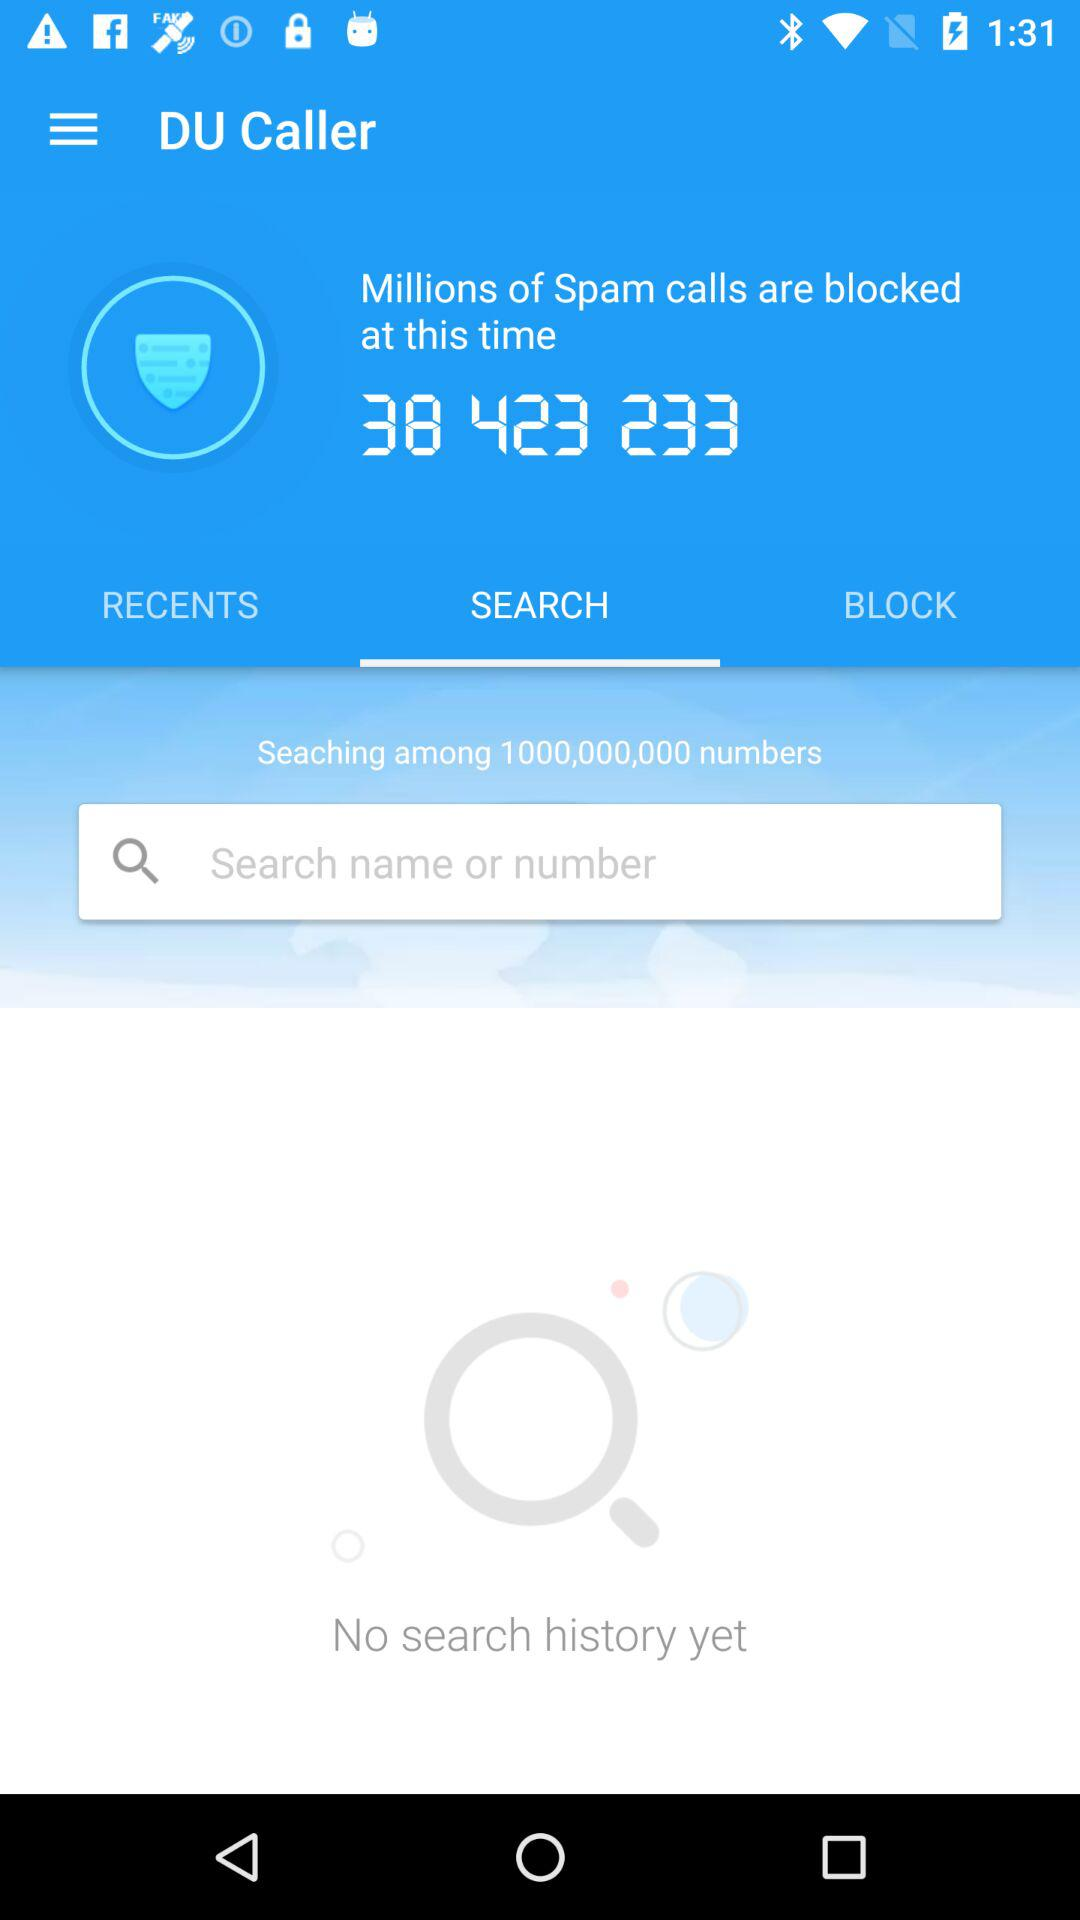Is there any history present on the screen? There is no search history on the screen. 